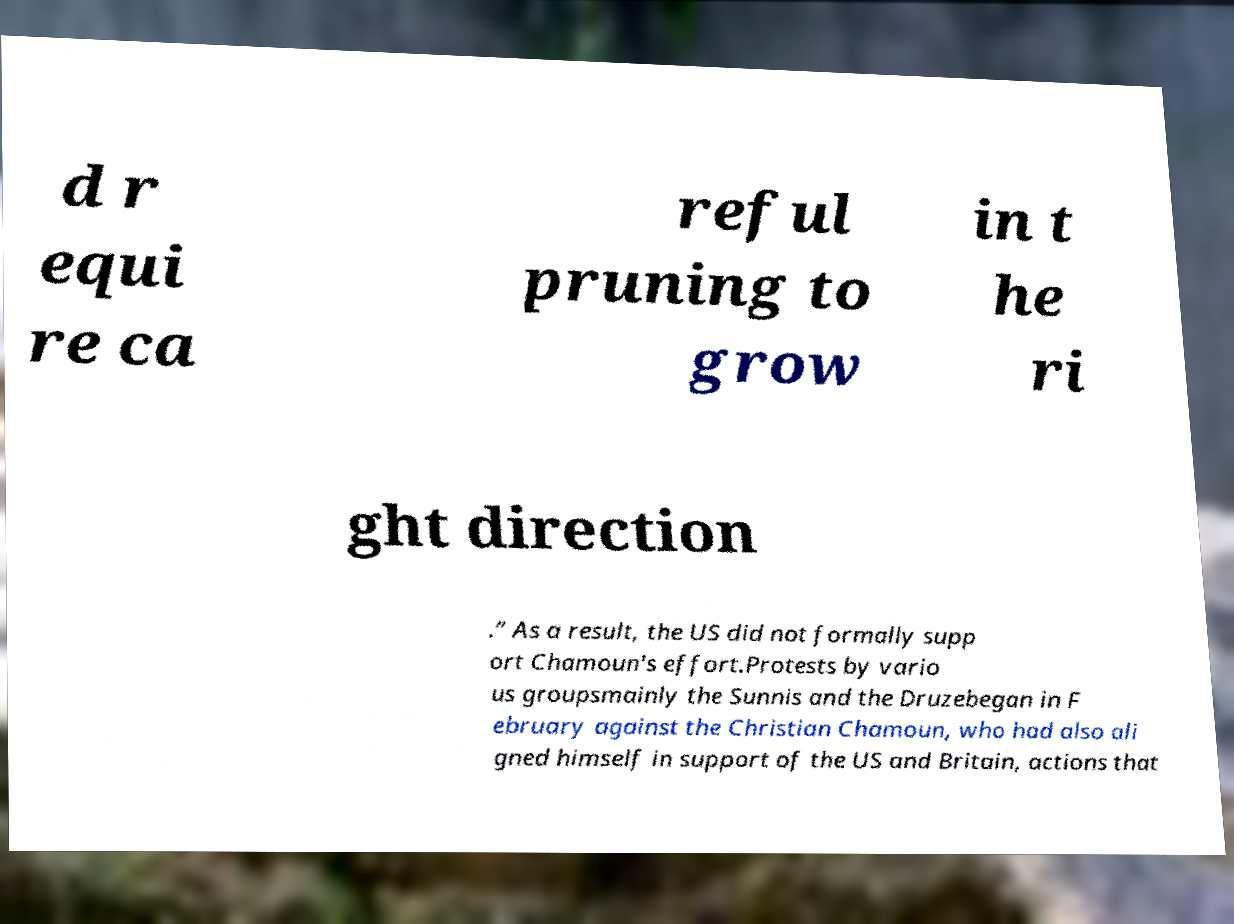Could you extract and type out the text from this image? d r equi re ca reful pruning to grow in t he ri ght direction .” As a result, the US did not formally supp ort Chamoun's effort.Protests by vario us groupsmainly the Sunnis and the Druzebegan in F ebruary against the Christian Chamoun, who had also ali gned himself in support of the US and Britain, actions that 